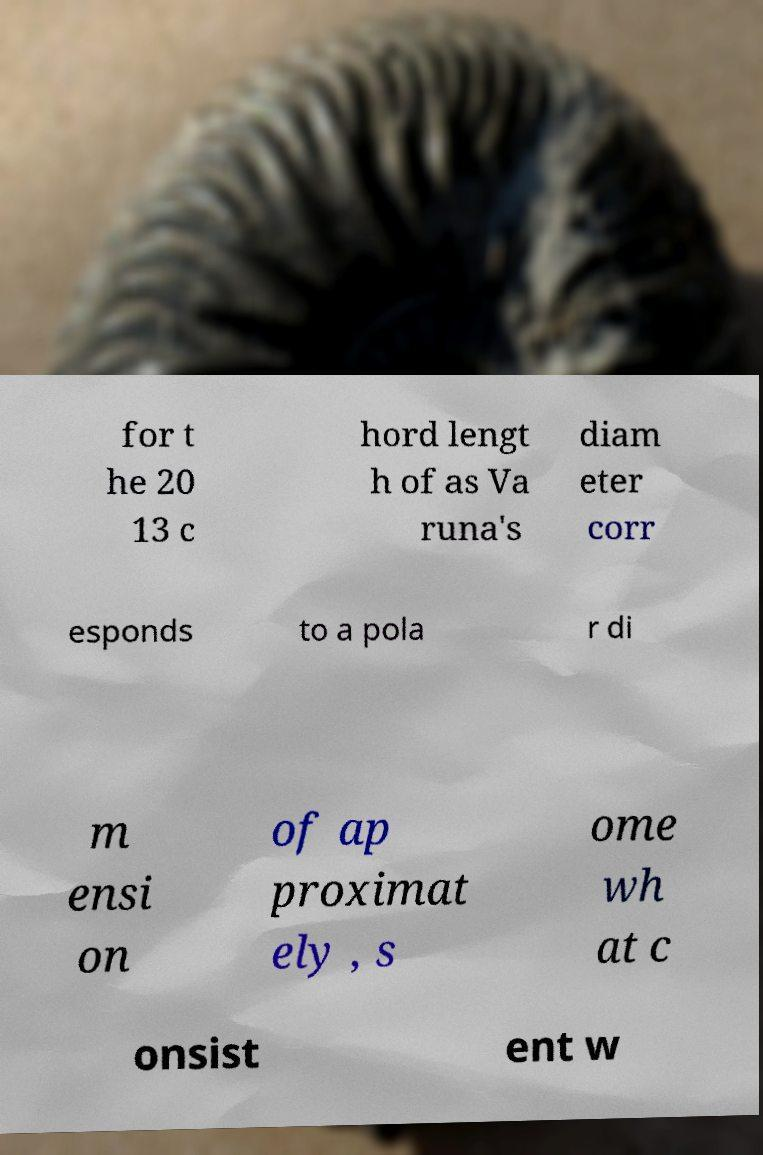Can you accurately transcribe the text from the provided image for me? for t he 20 13 c hord lengt h of as Va runa's diam eter corr esponds to a pola r di m ensi on of ap proximat ely , s ome wh at c onsist ent w 